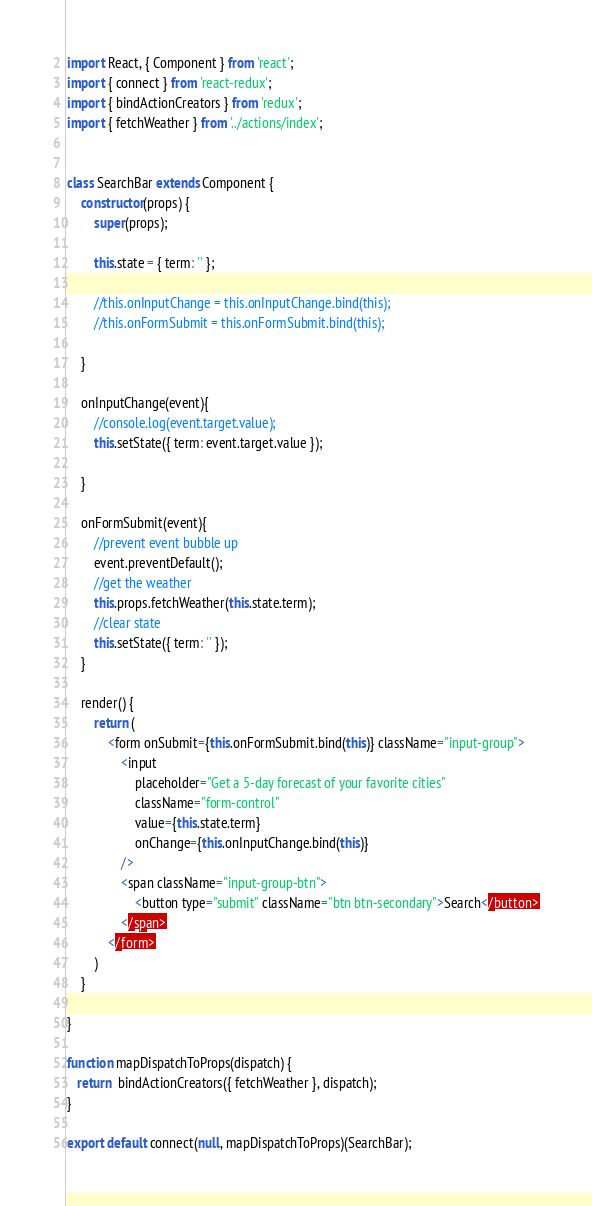<code> <loc_0><loc_0><loc_500><loc_500><_JavaScript_>import React, { Component } from 'react';
import { connect } from 'react-redux';
import { bindActionCreators } from 'redux';
import { fetchWeather } from '../actions/index';


class SearchBar extends Component {
    constructor(props) {
        super(props);

        this.state = { term: '' };

        //this.onInputChange = this.onInputChange.bind(this);
        //this.onFormSubmit = this.onFormSubmit.bind(this);
        
    }

    onInputChange(event){
        //console.log(event.target.value);
        this.setState({ term: event.target.value });

    }

    onFormSubmit(event){
        //prevent event bubble up
        event.preventDefault();
        //get the weather
        this.props.fetchWeather(this.state.term);
        //clear state
        this.setState({ term: '' });
    }

    render() {
        return (
            <form onSubmit={this.onFormSubmit.bind(this)} className="input-group">
                <input 
                    placeholder="Get a 5-day forecast of your favorite cities"
                    className="form-control"
                    value={this.state.term}
                    onChange={this.onInputChange.bind(this)}
                />
                <span className="input-group-btn">
                    <button type="submit" className="btn btn-secondary">Search</button>
                </span>
            </form>
        )
    }
    
}

function mapDispatchToProps(dispatch) {
   return  bindActionCreators({ fetchWeather }, dispatch);
}

export default connect(null, mapDispatchToProps)(SearchBar);


</code> 